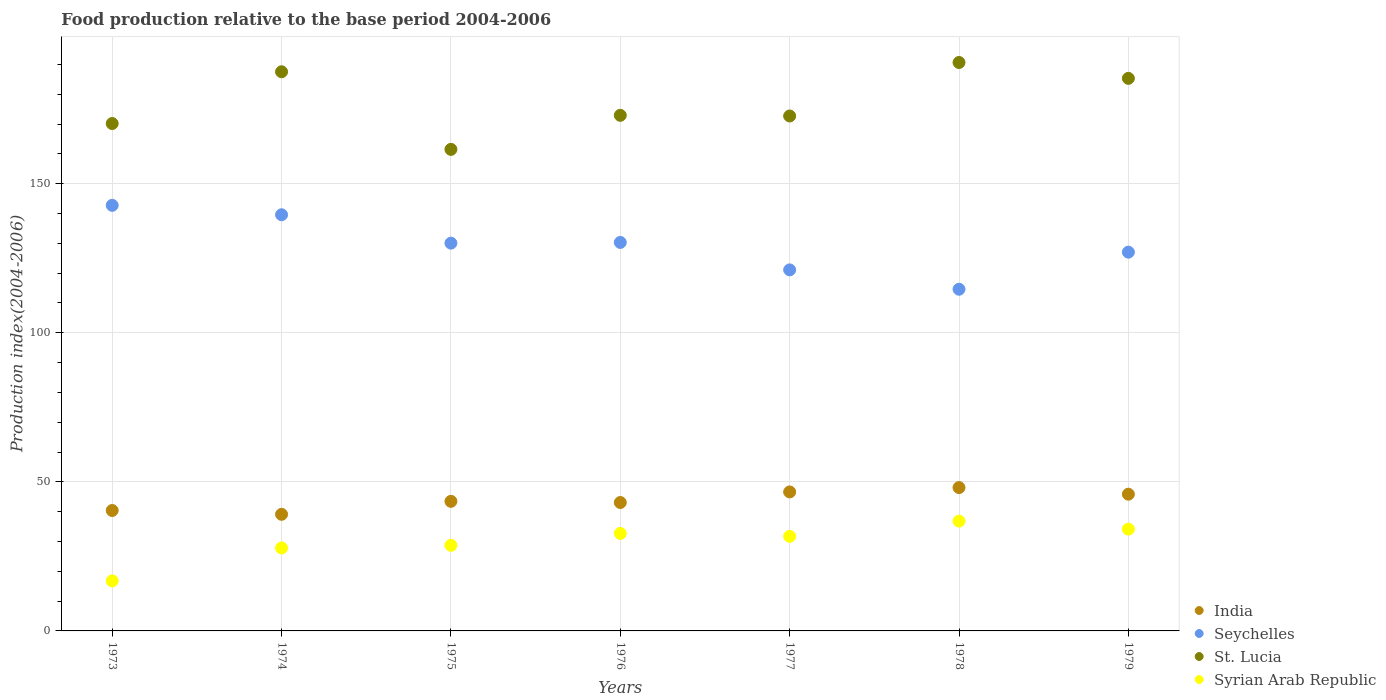What is the food production index in Syrian Arab Republic in 1978?
Your response must be concise. 36.83. Across all years, what is the maximum food production index in Seychelles?
Your answer should be compact. 142.74. Across all years, what is the minimum food production index in Syrian Arab Republic?
Offer a terse response. 16.78. In which year was the food production index in Syrian Arab Republic maximum?
Make the answer very short. 1978. In which year was the food production index in Syrian Arab Republic minimum?
Your answer should be compact. 1973. What is the total food production index in St. Lucia in the graph?
Give a very brief answer. 1240.85. What is the difference between the food production index in India in 1977 and that in 1978?
Provide a succinct answer. -1.46. What is the difference between the food production index in St. Lucia in 1973 and the food production index in Seychelles in 1978?
Keep it short and to the point. 55.58. What is the average food production index in Syrian Arab Republic per year?
Provide a short and direct response. 29.81. In the year 1973, what is the difference between the food production index in Seychelles and food production index in Syrian Arab Republic?
Offer a terse response. 125.96. In how many years, is the food production index in Seychelles greater than 10?
Provide a succinct answer. 7. What is the ratio of the food production index in India in 1973 to that in 1974?
Offer a very short reply. 1.03. What is the difference between the highest and the second highest food production index in St. Lucia?
Your answer should be very brief. 3.11. What is the difference between the highest and the lowest food production index in Syrian Arab Republic?
Provide a short and direct response. 20.05. Is the sum of the food production index in Syrian Arab Republic in 1973 and 1976 greater than the maximum food production index in India across all years?
Offer a very short reply. Yes. Is it the case that in every year, the sum of the food production index in Seychelles and food production index in St. Lucia  is greater than the sum of food production index in Syrian Arab Republic and food production index in India?
Your answer should be compact. Yes. Is it the case that in every year, the sum of the food production index in St. Lucia and food production index in Seychelles  is greater than the food production index in Syrian Arab Republic?
Your answer should be compact. Yes. Is the food production index in Syrian Arab Republic strictly greater than the food production index in India over the years?
Provide a short and direct response. No. Is the food production index in Seychelles strictly less than the food production index in St. Lucia over the years?
Give a very brief answer. Yes. How many dotlines are there?
Provide a succinct answer. 4. What is the difference between two consecutive major ticks on the Y-axis?
Your response must be concise. 50. Are the values on the major ticks of Y-axis written in scientific E-notation?
Keep it short and to the point. No. Does the graph contain any zero values?
Give a very brief answer. No. Does the graph contain grids?
Your answer should be very brief. Yes. Where does the legend appear in the graph?
Offer a terse response. Bottom right. How many legend labels are there?
Provide a short and direct response. 4. How are the legend labels stacked?
Provide a succinct answer. Vertical. What is the title of the graph?
Keep it short and to the point. Food production relative to the base period 2004-2006. What is the label or title of the Y-axis?
Make the answer very short. Production index(2004-2006). What is the Production index(2004-2006) of India in 1973?
Ensure brevity in your answer.  40.39. What is the Production index(2004-2006) in Seychelles in 1973?
Keep it short and to the point. 142.74. What is the Production index(2004-2006) in St. Lucia in 1973?
Your answer should be compact. 170.18. What is the Production index(2004-2006) of Syrian Arab Republic in 1973?
Ensure brevity in your answer.  16.78. What is the Production index(2004-2006) in India in 1974?
Ensure brevity in your answer.  39.11. What is the Production index(2004-2006) in Seychelles in 1974?
Give a very brief answer. 139.58. What is the Production index(2004-2006) of St. Lucia in 1974?
Keep it short and to the point. 187.54. What is the Production index(2004-2006) of Syrian Arab Republic in 1974?
Provide a short and direct response. 27.83. What is the Production index(2004-2006) in India in 1975?
Ensure brevity in your answer.  43.46. What is the Production index(2004-2006) of Seychelles in 1975?
Give a very brief answer. 130.06. What is the Production index(2004-2006) in St. Lucia in 1975?
Your answer should be compact. 161.51. What is the Production index(2004-2006) of Syrian Arab Republic in 1975?
Your answer should be very brief. 28.7. What is the Production index(2004-2006) in India in 1976?
Your answer should be very brief. 43.07. What is the Production index(2004-2006) in Seychelles in 1976?
Your answer should be compact. 130.3. What is the Production index(2004-2006) in St. Lucia in 1976?
Provide a short and direct response. 172.93. What is the Production index(2004-2006) of Syrian Arab Republic in 1976?
Your answer should be very brief. 32.69. What is the Production index(2004-2006) in India in 1977?
Provide a succinct answer. 46.62. What is the Production index(2004-2006) of Seychelles in 1977?
Ensure brevity in your answer.  121.09. What is the Production index(2004-2006) in St. Lucia in 1977?
Give a very brief answer. 172.71. What is the Production index(2004-2006) in Syrian Arab Republic in 1977?
Make the answer very short. 31.72. What is the Production index(2004-2006) of India in 1978?
Your response must be concise. 48.08. What is the Production index(2004-2006) in Seychelles in 1978?
Provide a short and direct response. 114.6. What is the Production index(2004-2006) of St. Lucia in 1978?
Ensure brevity in your answer.  190.65. What is the Production index(2004-2006) in Syrian Arab Republic in 1978?
Offer a very short reply. 36.83. What is the Production index(2004-2006) of India in 1979?
Give a very brief answer. 45.86. What is the Production index(2004-2006) of Seychelles in 1979?
Keep it short and to the point. 127.04. What is the Production index(2004-2006) of St. Lucia in 1979?
Make the answer very short. 185.33. What is the Production index(2004-2006) in Syrian Arab Republic in 1979?
Your answer should be compact. 34.15. Across all years, what is the maximum Production index(2004-2006) in India?
Your answer should be very brief. 48.08. Across all years, what is the maximum Production index(2004-2006) in Seychelles?
Keep it short and to the point. 142.74. Across all years, what is the maximum Production index(2004-2006) of St. Lucia?
Offer a very short reply. 190.65. Across all years, what is the maximum Production index(2004-2006) in Syrian Arab Republic?
Provide a short and direct response. 36.83. Across all years, what is the minimum Production index(2004-2006) of India?
Make the answer very short. 39.11. Across all years, what is the minimum Production index(2004-2006) of Seychelles?
Offer a terse response. 114.6. Across all years, what is the minimum Production index(2004-2006) of St. Lucia?
Provide a short and direct response. 161.51. Across all years, what is the minimum Production index(2004-2006) of Syrian Arab Republic?
Keep it short and to the point. 16.78. What is the total Production index(2004-2006) of India in the graph?
Make the answer very short. 306.59. What is the total Production index(2004-2006) in Seychelles in the graph?
Make the answer very short. 905.41. What is the total Production index(2004-2006) in St. Lucia in the graph?
Offer a terse response. 1240.85. What is the total Production index(2004-2006) of Syrian Arab Republic in the graph?
Offer a very short reply. 208.7. What is the difference between the Production index(2004-2006) in India in 1973 and that in 1974?
Keep it short and to the point. 1.28. What is the difference between the Production index(2004-2006) of Seychelles in 1973 and that in 1974?
Give a very brief answer. 3.16. What is the difference between the Production index(2004-2006) of St. Lucia in 1973 and that in 1974?
Keep it short and to the point. -17.36. What is the difference between the Production index(2004-2006) of Syrian Arab Republic in 1973 and that in 1974?
Provide a short and direct response. -11.05. What is the difference between the Production index(2004-2006) in India in 1973 and that in 1975?
Ensure brevity in your answer.  -3.07. What is the difference between the Production index(2004-2006) in Seychelles in 1973 and that in 1975?
Keep it short and to the point. 12.68. What is the difference between the Production index(2004-2006) of St. Lucia in 1973 and that in 1975?
Ensure brevity in your answer.  8.67. What is the difference between the Production index(2004-2006) in Syrian Arab Republic in 1973 and that in 1975?
Offer a very short reply. -11.92. What is the difference between the Production index(2004-2006) of India in 1973 and that in 1976?
Offer a very short reply. -2.68. What is the difference between the Production index(2004-2006) of Seychelles in 1973 and that in 1976?
Offer a very short reply. 12.44. What is the difference between the Production index(2004-2006) in St. Lucia in 1973 and that in 1976?
Your answer should be compact. -2.75. What is the difference between the Production index(2004-2006) of Syrian Arab Republic in 1973 and that in 1976?
Make the answer very short. -15.91. What is the difference between the Production index(2004-2006) of India in 1973 and that in 1977?
Your answer should be very brief. -6.23. What is the difference between the Production index(2004-2006) in Seychelles in 1973 and that in 1977?
Give a very brief answer. 21.65. What is the difference between the Production index(2004-2006) in St. Lucia in 1973 and that in 1977?
Provide a short and direct response. -2.53. What is the difference between the Production index(2004-2006) in Syrian Arab Republic in 1973 and that in 1977?
Your answer should be very brief. -14.94. What is the difference between the Production index(2004-2006) of India in 1973 and that in 1978?
Provide a succinct answer. -7.69. What is the difference between the Production index(2004-2006) in Seychelles in 1973 and that in 1978?
Your response must be concise. 28.14. What is the difference between the Production index(2004-2006) of St. Lucia in 1973 and that in 1978?
Make the answer very short. -20.47. What is the difference between the Production index(2004-2006) in Syrian Arab Republic in 1973 and that in 1978?
Make the answer very short. -20.05. What is the difference between the Production index(2004-2006) in India in 1973 and that in 1979?
Offer a terse response. -5.47. What is the difference between the Production index(2004-2006) of Seychelles in 1973 and that in 1979?
Provide a short and direct response. 15.7. What is the difference between the Production index(2004-2006) of St. Lucia in 1973 and that in 1979?
Provide a succinct answer. -15.15. What is the difference between the Production index(2004-2006) of Syrian Arab Republic in 1973 and that in 1979?
Ensure brevity in your answer.  -17.37. What is the difference between the Production index(2004-2006) of India in 1974 and that in 1975?
Offer a terse response. -4.35. What is the difference between the Production index(2004-2006) of Seychelles in 1974 and that in 1975?
Your response must be concise. 9.52. What is the difference between the Production index(2004-2006) in St. Lucia in 1974 and that in 1975?
Offer a very short reply. 26.03. What is the difference between the Production index(2004-2006) in Syrian Arab Republic in 1974 and that in 1975?
Give a very brief answer. -0.87. What is the difference between the Production index(2004-2006) in India in 1974 and that in 1976?
Your answer should be very brief. -3.96. What is the difference between the Production index(2004-2006) of Seychelles in 1974 and that in 1976?
Offer a very short reply. 9.28. What is the difference between the Production index(2004-2006) of St. Lucia in 1974 and that in 1976?
Your response must be concise. 14.61. What is the difference between the Production index(2004-2006) of Syrian Arab Republic in 1974 and that in 1976?
Your response must be concise. -4.86. What is the difference between the Production index(2004-2006) in India in 1974 and that in 1977?
Offer a terse response. -7.51. What is the difference between the Production index(2004-2006) in Seychelles in 1974 and that in 1977?
Your response must be concise. 18.49. What is the difference between the Production index(2004-2006) of St. Lucia in 1974 and that in 1977?
Offer a terse response. 14.83. What is the difference between the Production index(2004-2006) in Syrian Arab Republic in 1974 and that in 1977?
Ensure brevity in your answer.  -3.89. What is the difference between the Production index(2004-2006) of India in 1974 and that in 1978?
Provide a succinct answer. -8.97. What is the difference between the Production index(2004-2006) in Seychelles in 1974 and that in 1978?
Offer a terse response. 24.98. What is the difference between the Production index(2004-2006) in St. Lucia in 1974 and that in 1978?
Your answer should be compact. -3.11. What is the difference between the Production index(2004-2006) in Syrian Arab Republic in 1974 and that in 1978?
Give a very brief answer. -9. What is the difference between the Production index(2004-2006) of India in 1974 and that in 1979?
Offer a very short reply. -6.75. What is the difference between the Production index(2004-2006) of Seychelles in 1974 and that in 1979?
Offer a terse response. 12.54. What is the difference between the Production index(2004-2006) in St. Lucia in 1974 and that in 1979?
Offer a terse response. 2.21. What is the difference between the Production index(2004-2006) of Syrian Arab Republic in 1974 and that in 1979?
Ensure brevity in your answer.  -6.32. What is the difference between the Production index(2004-2006) of India in 1975 and that in 1976?
Your answer should be compact. 0.39. What is the difference between the Production index(2004-2006) of Seychelles in 1975 and that in 1976?
Make the answer very short. -0.24. What is the difference between the Production index(2004-2006) in St. Lucia in 1975 and that in 1976?
Offer a terse response. -11.42. What is the difference between the Production index(2004-2006) of Syrian Arab Republic in 1975 and that in 1976?
Your response must be concise. -3.99. What is the difference between the Production index(2004-2006) of India in 1975 and that in 1977?
Offer a very short reply. -3.16. What is the difference between the Production index(2004-2006) of Seychelles in 1975 and that in 1977?
Keep it short and to the point. 8.97. What is the difference between the Production index(2004-2006) of St. Lucia in 1975 and that in 1977?
Provide a succinct answer. -11.2. What is the difference between the Production index(2004-2006) of Syrian Arab Republic in 1975 and that in 1977?
Ensure brevity in your answer.  -3.02. What is the difference between the Production index(2004-2006) in India in 1975 and that in 1978?
Make the answer very short. -4.62. What is the difference between the Production index(2004-2006) in Seychelles in 1975 and that in 1978?
Keep it short and to the point. 15.46. What is the difference between the Production index(2004-2006) in St. Lucia in 1975 and that in 1978?
Offer a terse response. -29.14. What is the difference between the Production index(2004-2006) of Syrian Arab Republic in 1975 and that in 1978?
Keep it short and to the point. -8.13. What is the difference between the Production index(2004-2006) of Seychelles in 1975 and that in 1979?
Your answer should be compact. 3.02. What is the difference between the Production index(2004-2006) of St. Lucia in 1975 and that in 1979?
Ensure brevity in your answer.  -23.82. What is the difference between the Production index(2004-2006) of Syrian Arab Republic in 1975 and that in 1979?
Your response must be concise. -5.45. What is the difference between the Production index(2004-2006) of India in 1976 and that in 1977?
Keep it short and to the point. -3.55. What is the difference between the Production index(2004-2006) of Seychelles in 1976 and that in 1977?
Provide a succinct answer. 9.21. What is the difference between the Production index(2004-2006) of St. Lucia in 1976 and that in 1977?
Offer a terse response. 0.22. What is the difference between the Production index(2004-2006) of India in 1976 and that in 1978?
Make the answer very short. -5.01. What is the difference between the Production index(2004-2006) of St. Lucia in 1976 and that in 1978?
Offer a terse response. -17.72. What is the difference between the Production index(2004-2006) in Syrian Arab Republic in 1976 and that in 1978?
Your response must be concise. -4.14. What is the difference between the Production index(2004-2006) of India in 1976 and that in 1979?
Offer a very short reply. -2.79. What is the difference between the Production index(2004-2006) of Seychelles in 1976 and that in 1979?
Provide a short and direct response. 3.26. What is the difference between the Production index(2004-2006) in Syrian Arab Republic in 1976 and that in 1979?
Ensure brevity in your answer.  -1.46. What is the difference between the Production index(2004-2006) of India in 1977 and that in 1978?
Ensure brevity in your answer.  -1.46. What is the difference between the Production index(2004-2006) in Seychelles in 1977 and that in 1978?
Keep it short and to the point. 6.49. What is the difference between the Production index(2004-2006) in St. Lucia in 1977 and that in 1978?
Keep it short and to the point. -17.94. What is the difference between the Production index(2004-2006) of Syrian Arab Republic in 1977 and that in 1978?
Your answer should be compact. -5.11. What is the difference between the Production index(2004-2006) of India in 1977 and that in 1979?
Offer a very short reply. 0.76. What is the difference between the Production index(2004-2006) of Seychelles in 1977 and that in 1979?
Give a very brief answer. -5.95. What is the difference between the Production index(2004-2006) of St. Lucia in 1977 and that in 1979?
Make the answer very short. -12.62. What is the difference between the Production index(2004-2006) in Syrian Arab Republic in 1977 and that in 1979?
Your answer should be very brief. -2.43. What is the difference between the Production index(2004-2006) of India in 1978 and that in 1979?
Your response must be concise. 2.22. What is the difference between the Production index(2004-2006) of Seychelles in 1978 and that in 1979?
Provide a succinct answer. -12.44. What is the difference between the Production index(2004-2006) in St. Lucia in 1978 and that in 1979?
Give a very brief answer. 5.32. What is the difference between the Production index(2004-2006) of Syrian Arab Republic in 1978 and that in 1979?
Provide a succinct answer. 2.68. What is the difference between the Production index(2004-2006) in India in 1973 and the Production index(2004-2006) in Seychelles in 1974?
Your answer should be very brief. -99.19. What is the difference between the Production index(2004-2006) in India in 1973 and the Production index(2004-2006) in St. Lucia in 1974?
Ensure brevity in your answer.  -147.15. What is the difference between the Production index(2004-2006) of India in 1973 and the Production index(2004-2006) of Syrian Arab Republic in 1974?
Provide a succinct answer. 12.56. What is the difference between the Production index(2004-2006) of Seychelles in 1973 and the Production index(2004-2006) of St. Lucia in 1974?
Make the answer very short. -44.8. What is the difference between the Production index(2004-2006) of Seychelles in 1973 and the Production index(2004-2006) of Syrian Arab Republic in 1974?
Provide a short and direct response. 114.91. What is the difference between the Production index(2004-2006) of St. Lucia in 1973 and the Production index(2004-2006) of Syrian Arab Republic in 1974?
Make the answer very short. 142.35. What is the difference between the Production index(2004-2006) in India in 1973 and the Production index(2004-2006) in Seychelles in 1975?
Provide a succinct answer. -89.67. What is the difference between the Production index(2004-2006) in India in 1973 and the Production index(2004-2006) in St. Lucia in 1975?
Make the answer very short. -121.12. What is the difference between the Production index(2004-2006) in India in 1973 and the Production index(2004-2006) in Syrian Arab Republic in 1975?
Ensure brevity in your answer.  11.69. What is the difference between the Production index(2004-2006) of Seychelles in 1973 and the Production index(2004-2006) of St. Lucia in 1975?
Your response must be concise. -18.77. What is the difference between the Production index(2004-2006) of Seychelles in 1973 and the Production index(2004-2006) of Syrian Arab Republic in 1975?
Your response must be concise. 114.04. What is the difference between the Production index(2004-2006) in St. Lucia in 1973 and the Production index(2004-2006) in Syrian Arab Republic in 1975?
Offer a terse response. 141.48. What is the difference between the Production index(2004-2006) in India in 1973 and the Production index(2004-2006) in Seychelles in 1976?
Keep it short and to the point. -89.91. What is the difference between the Production index(2004-2006) of India in 1973 and the Production index(2004-2006) of St. Lucia in 1976?
Ensure brevity in your answer.  -132.54. What is the difference between the Production index(2004-2006) of India in 1973 and the Production index(2004-2006) of Syrian Arab Republic in 1976?
Offer a terse response. 7.7. What is the difference between the Production index(2004-2006) of Seychelles in 1973 and the Production index(2004-2006) of St. Lucia in 1976?
Your answer should be compact. -30.19. What is the difference between the Production index(2004-2006) in Seychelles in 1973 and the Production index(2004-2006) in Syrian Arab Republic in 1976?
Your answer should be very brief. 110.05. What is the difference between the Production index(2004-2006) of St. Lucia in 1973 and the Production index(2004-2006) of Syrian Arab Republic in 1976?
Provide a short and direct response. 137.49. What is the difference between the Production index(2004-2006) in India in 1973 and the Production index(2004-2006) in Seychelles in 1977?
Make the answer very short. -80.7. What is the difference between the Production index(2004-2006) of India in 1973 and the Production index(2004-2006) of St. Lucia in 1977?
Give a very brief answer. -132.32. What is the difference between the Production index(2004-2006) of India in 1973 and the Production index(2004-2006) of Syrian Arab Republic in 1977?
Ensure brevity in your answer.  8.67. What is the difference between the Production index(2004-2006) in Seychelles in 1973 and the Production index(2004-2006) in St. Lucia in 1977?
Keep it short and to the point. -29.97. What is the difference between the Production index(2004-2006) of Seychelles in 1973 and the Production index(2004-2006) of Syrian Arab Republic in 1977?
Keep it short and to the point. 111.02. What is the difference between the Production index(2004-2006) in St. Lucia in 1973 and the Production index(2004-2006) in Syrian Arab Republic in 1977?
Make the answer very short. 138.46. What is the difference between the Production index(2004-2006) of India in 1973 and the Production index(2004-2006) of Seychelles in 1978?
Your answer should be compact. -74.21. What is the difference between the Production index(2004-2006) of India in 1973 and the Production index(2004-2006) of St. Lucia in 1978?
Your answer should be compact. -150.26. What is the difference between the Production index(2004-2006) in India in 1973 and the Production index(2004-2006) in Syrian Arab Republic in 1978?
Ensure brevity in your answer.  3.56. What is the difference between the Production index(2004-2006) in Seychelles in 1973 and the Production index(2004-2006) in St. Lucia in 1978?
Make the answer very short. -47.91. What is the difference between the Production index(2004-2006) of Seychelles in 1973 and the Production index(2004-2006) of Syrian Arab Republic in 1978?
Keep it short and to the point. 105.91. What is the difference between the Production index(2004-2006) in St. Lucia in 1973 and the Production index(2004-2006) in Syrian Arab Republic in 1978?
Your answer should be compact. 133.35. What is the difference between the Production index(2004-2006) in India in 1973 and the Production index(2004-2006) in Seychelles in 1979?
Offer a very short reply. -86.65. What is the difference between the Production index(2004-2006) of India in 1973 and the Production index(2004-2006) of St. Lucia in 1979?
Keep it short and to the point. -144.94. What is the difference between the Production index(2004-2006) of India in 1973 and the Production index(2004-2006) of Syrian Arab Republic in 1979?
Your answer should be very brief. 6.24. What is the difference between the Production index(2004-2006) in Seychelles in 1973 and the Production index(2004-2006) in St. Lucia in 1979?
Your answer should be very brief. -42.59. What is the difference between the Production index(2004-2006) in Seychelles in 1973 and the Production index(2004-2006) in Syrian Arab Republic in 1979?
Ensure brevity in your answer.  108.59. What is the difference between the Production index(2004-2006) of St. Lucia in 1973 and the Production index(2004-2006) of Syrian Arab Republic in 1979?
Provide a short and direct response. 136.03. What is the difference between the Production index(2004-2006) in India in 1974 and the Production index(2004-2006) in Seychelles in 1975?
Give a very brief answer. -90.95. What is the difference between the Production index(2004-2006) in India in 1974 and the Production index(2004-2006) in St. Lucia in 1975?
Ensure brevity in your answer.  -122.4. What is the difference between the Production index(2004-2006) in India in 1974 and the Production index(2004-2006) in Syrian Arab Republic in 1975?
Keep it short and to the point. 10.41. What is the difference between the Production index(2004-2006) in Seychelles in 1974 and the Production index(2004-2006) in St. Lucia in 1975?
Make the answer very short. -21.93. What is the difference between the Production index(2004-2006) of Seychelles in 1974 and the Production index(2004-2006) of Syrian Arab Republic in 1975?
Make the answer very short. 110.88. What is the difference between the Production index(2004-2006) in St. Lucia in 1974 and the Production index(2004-2006) in Syrian Arab Republic in 1975?
Your answer should be very brief. 158.84. What is the difference between the Production index(2004-2006) in India in 1974 and the Production index(2004-2006) in Seychelles in 1976?
Provide a short and direct response. -91.19. What is the difference between the Production index(2004-2006) of India in 1974 and the Production index(2004-2006) of St. Lucia in 1976?
Your response must be concise. -133.82. What is the difference between the Production index(2004-2006) of India in 1974 and the Production index(2004-2006) of Syrian Arab Republic in 1976?
Ensure brevity in your answer.  6.42. What is the difference between the Production index(2004-2006) of Seychelles in 1974 and the Production index(2004-2006) of St. Lucia in 1976?
Make the answer very short. -33.35. What is the difference between the Production index(2004-2006) in Seychelles in 1974 and the Production index(2004-2006) in Syrian Arab Republic in 1976?
Your response must be concise. 106.89. What is the difference between the Production index(2004-2006) of St. Lucia in 1974 and the Production index(2004-2006) of Syrian Arab Republic in 1976?
Make the answer very short. 154.85. What is the difference between the Production index(2004-2006) of India in 1974 and the Production index(2004-2006) of Seychelles in 1977?
Provide a succinct answer. -81.98. What is the difference between the Production index(2004-2006) of India in 1974 and the Production index(2004-2006) of St. Lucia in 1977?
Provide a short and direct response. -133.6. What is the difference between the Production index(2004-2006) of India in 1974 and the Production index(2004-2006) of Syrian Arab Republic in 1977?
Make the answer very short. 7.39. What is the difference between the Production index(2004-2006) of Seychelles in 1974 and the Production index(2004-2006) of St. Lucia in 1977?
Your response must be concise. -33.13. What is the difference between the Production index(2004-2006) in Seychelles in 1974 and the Production index(2004-2006) in Syrian Arab Republic in 1977?
Your answer should be compact. 107.86. What is the difference between the Production index(2004-2006) of St. Lucia in 1974 and the Production index(2004-2006) of Syrian Arab Republic in 1977?
Keep it short and to the point. 155.82. What is the difference between the Production index(2004-2006) of India in 1974 and the Production index(2004-2006) of Seychelles in 1978?
Your response must be concise. -75.49. What is the difference between the Production index(2004-2006) in India in 1974 and the Production index(2004-2006) in St. Lucia in 1978?
Keep it short and to the point. -151.54. What is the difference between the Production index(2004-2006) of India in 1974 and the Production index(2004-2006) of Syrian Arab Republic in 1978?
Offer a terse response. 2.28. What is the difference between the Production index(2004-2006) in Seychelles in 1974 and the Production index(2004-2006) in St. Lucia in 1978?
Ensure brevity in your answer.  -51.07. What is the difference between the Production index(2004-2006) in Seychelles in 1974 and the Production index(2004-2006) in Syrian Arab Republic in 1978?
Ensure brevity in your answer.  102.75. What is the difference between the Production index(2004-2006) in St. Lucia in 1974 and the Production index(2004-2006) in Syrian Arab Republic in 1978?
Your response must be concise. 150.71. What is the difference between the Production index(2004-2006) of India in 1974 and the Production index(2004-2006) of Seychelles in 1979?
Provide a short and direct response. -87.93. What is the difference between the Production index(2004-2006) of India in 1974 and the Production index(2004-2006) of St. Lucia in 1979?
Provide a succinct answer. -146.22. What is the difference between the Production index(2004-2006) in India in 1974 and the Production index(2004-2006) in Syrian Arab Republic in 1979?
Offer a terse response. 4.96. What is the difference between the Production index(2004-2006) in Seychelles in 1974 and the Production index(2004-2006) in St. Lucia in 1979?
Provide a succinct answer. -45.75. What is the difference between the Production index(2004-2006) in Seychelles in 1974 and the Production index(2004-2006) in Syrian Arab Republic in 1979?
Your response must be concise. 105.43. What is the difference between the Production index(2004-2006) of St. Lucia in 1974 and the Production index(2004-2006) of Syrian Arab Republic in 1979?
Ensure brevity in your answer.  153.39. What is the difference between the Production index(2004-2006) in India in 1975 and the Production index(2004-2006) in Seychelles in 1976?
Your answer should be compact. -86.84. What is the difference between the Production index(2004-2006) in India in 1975 and the Production index(2004-2006) in St. Lucia in 1976?
Your answer should be compact. -129.47. What is the difference between the Production index(2004-2006) in India in 1975 and the Production index(2004-2006) in Syrian Arab Republic in 1976?
Your answer should be very brief. 10.77. What is the difference between the Production index(2004-2006) of Seychelles in 1975 and the Production index(2004-2006) of St. Lucia in 1976?
Your answer should be compact. -42.87. What is the difference between the Production index(2004-2006) of Seychelles in 1975 and the Production index(2004-2006) of Syrian Arab Republic in 1976?
Your answer should be very brief. 97.37. What is the difference between the Production index(2004-2006) of St. Lucia in 1975 and the Production index(2004-2006) of Syrian Arab Republic in 1976?
Provide a succinct answer. 128.82. What is the difference between the Production index(2004-2006) of India in 1975 and the Production index(2004-2006) of Seychelles in 1977?
Offer a terse response. -77.63. What is the difference between the Production index(2004-2006) in India in 1975 and the Production index(2004-2006) in St. Lucia in 1977?
Your answer should be compact. -129.25. What is the difference between the Production index(2004-2006) in India in 1975 and the Production index(2004-2006) in Syrian Arab Republic in 1977?
Provide a succinct answer. 11.74. What is the difference between the Production index(2004-2006) in Seychelles in 1975 and the Production index(2004-2006) in St. Lucia in 1977?
Your answer should be compact. -42.65. What is the difference between the Production index(2004-2006) in Seychelles in 1975 and the Production index(2004-2006) in Syrian Arab Republic in 1977?
Provide a short and direct response. 98.34. What is the difference between the Production index(2004-2006) in St. Lucia in 1975 and the Production index(2004-2006) in Syrian Arab Republic in 1977?
Offer a terse response. 129.79. What is the difference between the Production index(2004-2006) of India in 1975 and the Production index(2004-2006) of Seychelles in 1978?
Provide a succinct answer. -71.14. What is the difference between the Production index(2004-2006) of India in 1975 and the Production index(2004-2006) of St. Lucia in 1978?
Your answer should be compact. -147.19. What is the difference between the Production index(2004-2006) of India in 1975 and the Production index(2004-2006) of Syrian Arab Republic in 1978?
Keep it short and to the point. 6.63. What is the difference between the Production index(2004-2006) in Seychelles in 1975 and the Production index(2004-2006) in St. Lucia in 1978?
Give a very brief answer. -60.59. What is the difference between the Production index(2004-2006) of Seychelles in 1975 and the Production index(2004-2006) of Syrian Arab Republic in 1978?
Your response must be concise. 93.23. What is the difference between the Production index(2004-2006) of St. Lucia in 1975 and the Production index(2004-2006) of Syrian Arab Republic in 1978?
Provide a succinct answer. 124.68. What is the difference between the Production index(2004-2006) of India in 1975 and the Production index(2004-2006) of Seychelles in 1979?
Make the answer very short. -83.58. What is the difference between the Production index(2004-2006) in India in 1975 and the Production index(2004-2006) in St. Lucia in 1979?
Provide a succinct answer. -141.87. What is the difference between the Production index(2004-2006) in India in 1975 and the Production index(2004-2006) in Syrian Arab Republic in 1979?
Ensure brevity in your answer.  9.31. What is the difference between the Production index(2004-2006) in Seychelles in 1975 and the Production index(2004-2006) in St. Lucia in 1979?
Keep it short and to the point. -55.27. What is the difference between the Production index(2004-2006) of Seychelles in 1975 and the Production index(2004-2006) of Syrian Arab Republic in 1979?
Ensure brevity in your answer.  95.91. What is the difference between the Production index(2004-2006) in St. Lucia in 1975 and the Production index(2004-2006) in Syrian Arab Republic in 1979?
Ensure brevity in your answer.  127.36. What is the difference between the Production index(2004-2006) of India in 1976 and the Production index(2004-2006) of Seychelles in 1977?
Give a very brief answer. -78.02. What is the difference between the Production index(2004-2006) of India in 1976 and the Production index(2004-2006) of St. Lucia in 1977?
Provide a succinct answer. -129.64. What is the difference between the Production index(2004-2006) of India in 1976 and the Production index(2004-2006) of Syrian Arab Republic in 1977?
Your answer should be compact. 11.35. What is the difference between the Production index(2004-2006) of Seychelles in 1976 and the Production index(2004-2006) of St. Lucia in 1977?
Ensure brevity in your answer.  -42.41. What is the difference between the Production index(2004-2006) of Seychelles in 1976 and the Production index(2004-2006) of Syrian Arab Republic in 1977?
Provide a short and direct response. 98.58. What is the difference between the Production index(2004-2006) of St. Lucia in 1976 and the Production index(2004-2006) of Syrian Arab Republic in 1977?
Ensure brevity in your answer.  141.21. What is the difference between the Production index(2004-2006) in India in 1976 and the Production index(2004-2006) in Seychelles in 1978?
Your answer should be very brief. -71.53. What is the difference between the Production index(2004-2006) of India in 1976 and the Production index(2004-2006) of St. Lucia in 1978?
Ensure brevity in your answer.  -147.58. What is the difference between the Production index(2004-2006) of India in 1976 and the Production index(2004-2006) of Syrian Arab Republic in 1978?
Provide a short and direct response. 6.24. What is the difference between the Production index(2004-2006) in Seychelles in 1976 and the Production index(2004-2006) in St. Lucia in 1978?
Your answer should be very brief. -60.35. What is the difference between the Production index(2004-2006) in Seychelles in 1976 and the Production index(2004-2006) in Syrian Arab Republic in 1978?
Provide a succinct answer. 93.47. What is the difference between the Production index(2004-2006) of St. Lucia in 1976 and the Production index(2004-2006) of Syrian Arab Republic in 1978?
Offer a very short reply. 136.1. What is the difference between the Production index(2004-2006) in India in 1976 and the Production index(2004-2006) in Seychelles in 1979?
Your answer should be compact. -83.97. What is the difference between the Production index(2004-2006) of India in 1976 and the Production index(2004-2006) of St. Lucia in 1979?
Give a very brief answer. -142.26. What is the difference between the Production index(2004-2006) in India in 1976 and the Production index(2004-2006) in Syrian Arab Republic in 1979?
Your answer should be compact. 8.92. What is the difference between the Production index(2004-2006) of Seychelles in 1976 and the Production index(2004-2006) of St. Lucia in 1979?
Provide a succinct answer. -55.03. What is the difference between the Production index(2004-2006) in Seychelles in 1976 and the Production index(2004-2006) in Syrian Arab Republic in 1979?
Offer a very short reply. 96.15. What is the difference between the Production index(2004-2006) in St. Lucia in 1976 and the Production index(2004-2006) in Syrian Arab Republic in 1979?
Provide a succinct answer. 138.78. What is the difference between the Production index(2004-2006) in India in 1977 and the Production index(2004-2006) in Seychelles in 1978?
Your answer should be compact. -67.98. What is the difference between the Production index(2004-2006) in India in 1977 and the Production index(2004-2006) in St. Lucia in 1978?
Your answer should be very brief. -144.03. What is the difference between the Production index(2004-2006) in India in 1977 and the Production index(2004-2006) in Syrian Arab Republic in 1978?
Make the answer very short. 9.79. What is the difference between the Production index(2004-2006) of Seychelles in 1977 and the Production index(2004-2006) of St. Lucia in 1978?
Ensure brevity in your answer.  -69.56. What is the difference between the Production index(2004-2006) of Seychelles in 1977 and the Production index(2004-2006) of Syrian Arab Republic in 1978?
Your answer should be compact. 84.26. What is the difference between the Production index(2004-2006) of St. Lucia in 1977 and the Production index(2004-2006) of Syrian Arab Republic in 1978?
Provide a succinct answer. 135.88. What is the difference between the Production index(2004-2006) in India in 1977 and the Production index(2004-2006) in Seychelles in 1979?
Give a very brief answer. -80.42. What is the difference between the Production index(2004-2006) of India in 1977 and the Production index(2004-2006) of St. Lucia in 1979?
Ensure brevity in your answer.  -138.71. What is the difference between the Production index(2004-2006) of India in 1977 and the Production index(2004-2006) of Syrian Arab Republic in 1979?
Your answer should be compact. 12.47. What is the difference between the Production index(2004-2006) in Seychelles in 1977 and the Production index(2004-2006) in St. Lucia in 1979?
Your response must be concise. -64.24. What is the difference between the Production index(2004-2006) of Seychelles in 1977 and the Production index(2004-2006) of Syrian Arab Republic in 1979?
Ensure brevity in your answer.  86.94. What is the difference between the Production index(2004-2006) of St. Lucia in 1977 and the Production index(2004-2006) of Syrian Arab Republic in 1979?
Ensure brevity in your answer.  138.56. What is the difference between the Production index(2004-2006) in India in 1978 and the Production index(2004-2006) in Seychelles in 1979?
Your answer should be compact. -78.96. What is the difference between the Production index(2004-2006) in India in 1978 and the Production index(2004-2006) in St. Lucia in 1979?
Make the answer very short. -137.25. What is the difference between the Production index(2004-2006) in India in 1978 and the Production index(2004-2006) in Syrian Arab Republic in 1979?
Ensure brevity in your answer.  13.93. What is the difference between the Production index(2004-2006) of Seychelles in 1978 and the Production index(2004-2006) of St. Lucia in 1979?
Give a very brief answer. -70.73. What is the difference between the Production index(2004-2006) in Seychelles in 1978 and the Production index(2004-2006) in Syrian Arab Republic in 1979?
Keep it short and to the point. 80.45. What is the difference between the Production index(2004-2006) of St. Lucia in 1978 and the Production index(2004-2006) of Syrian Arab Republic in 1979?
Keep it short and to the point. 156.5. What is the average Production index(2004-2006) in India per year?
Provide a succinct answer. 43.8. What is the average Production index(2004-2006) of Seychelles per year?
Keep it short and to the point. 129.34. What is the average Production index(2004-2006) of St. Lucia per year?
Your response must be concise. 177.26. What is the average Production index(2004-2006) of Syrian Arab Republic per year?
Provide a succinct answer. 29.81. In the year 1973, what is the difference between the Production index(2004-2006) of India and Production index(2004-2006) of Seychelles?
Provide a succinct answer. -102.35. In the year 1973, what is the difference between the Production index(2004-2006) of India and Production index(2004-2006) of St. Lucia?
Ensure brevity in your answer.  -129.79. In the year 1973, what is the difference between the Production index(2004-2006) of India and Production index(2004-2006) of Syrian Arab Republic?
Your response must be concise. 23.61. In the year 1973, what is the difference between the Production index(2004-2006) in Seychelles and Production index(2004-2006) in St. Lucia?
Provide a short and direct response. -27.44. In the year 1973, what is the difference between the Production index(2004-2006) of Seychelles and Production index(2004-2006) of Syrian Arab Republic?
Keep it short and to the point. 125.96. In the year 1973, what is the difference between the Production index(2004-2006) in St. Lucia and Production index(2004-2006) in Syrian Arab Republic?
Provide a succinct answer. 153.4. In the year 1974, what is the difference between the Production index(2004-2006) of India and Production index(2004-2006) of Seychelles?
Offer a terse response. -100.47. In the year 1974, what is the difference between the Production index(2004-2006) in India and Production index(2004-2006) in St. Lucia?
Your answer should be very brief. -148.43. In the year 1974, what is the difference between the Production index(2004-2006) in India and Production index(2004-2006) in Syrian Arab Republic?
Your answer should be very brief. 11.28. In the year 1974, what is the difference between the Production index(2004-2006) in Seychelles and Production index(2004-2006) in St. Lucia?
Give a very brief answer. -47.96. In the year 1974, what is the difference between the Production index(2004-2006) of Seychelles and Production index(2004-2006) of Syrian Arab Republic?
Give a very brief answer. 111.75. In the year 1974, what is the difference between the Production index(2004-2006) of St. Lucia and Production index(2004-2006) of Syrian Arab Republic?
Give a very brief answer. 159.71. In the year 1975, what is the difference between the Production index(2004-2006) of India and Production index(2004-2006) of Seychelles?
Make the answer very short. -86.6. In the year 1975, what is the difference between the Production index(2004-2006) of India and Production index(2004-2006) of St. Lucia?
Your answer should be compact. -118.05. In the year 1975, what is the difference between the Production index(2004-2006) in India and Production index(2004-2006) in Syrian Arab Republic?
Ensure brevity in your answer.  14.76. In the year 1975, what is the difference between the Production index(2004-2006) in Seychelles and Production index(2004-2006) in St. Lucia?
Keep it short and to the point. -31.45. In the year 1975, what is the difference between the Production index(2004-2006) of Seychelles and Production index(2004-2006) of Syrian Arab Republic?
Your response must be concise. 101.36. In the year 1975, what is the difference between the Production index(2004-2006) in St. Lucia and Production index(2004-2006) in Syrian Arab Republic?
Make the answer very short. 132.81. In the year 1976, what is the difference between the Production index(2004-2006) in India and Production index(2004-2006) in Seychelles?
Make the answer very short. -87.23. In the year 1976, what is the difference between the Production index(2004-2006) of India and Production index(2004-2006) of St. Lucia?
Ensure brevity in your answer.  -129.86. In the year 1976, what is the difference between the Production index(2004-2006) of India and Production index(2004-2006) of Syrian Arab Republic?
Ensure brevity in your answer.  10.38. In the year 1976, what is the difference between the Production index(2004-2006) of Seychelles and Production index(2004-2006) of St. Lucia?
Make the answer very short. -42.63. In the year 1976, what is the difference between the Production index(2004-2006) of Seychelles and Production index(2004-2006) of Syrian Arab Republic?
Ensure brevity in your answer.  97.61. In the year 1976, what is the difference between the Production index(2004-2006) in St. Lucia and Production index(2004-2006) in Syrian Arab Republic?
Give a very brief answer. 140.24. In the year 1977, what is the difference between the Production index(2004-2006) of India and Production index(2004-2006) of Seychelles?
Give a very brief answer. -74.47. In the year 1977, what is the difference between the Production index(2004-2006) of India and Production index(2004-2006) of St. Lucia?
Provide a short and direct response. -126.09. In the year 1977, what is the difference between the Production index(2004-2006) of India and Production index(2004-2006) of Syrian Arab Republic?
Provide a succinct answer. 14.9. In the year 1977, what is the difference between the Production index(2004-2006) in Seychelles and Production index(2004-2006) in St. Lucia?
Your answer should be compact. -51.62. In the year 1977, what is the difference between the Production index(2004-2006) in Seychelles and Production index(2004-2006) in Syrian Arab Republic?
Ensure brevity in your answer.  89.37. In the year 1977, what is the difference between the Production index(2004-2006) in St. Lucia and Production index(2004-2006) in Syrian Arab Republic?
Keep it short and to the point. 140.99. In the year 1978, what is the difference between the Production index(2004-2006) of India and Production index(2004-2006) of Seychelles?
Your response must be concise. -66.52. In the year 1978, what is the difference between the Production index(2004-2006) in India and Production index(2004-2006) in St. Lucia?
Provide a succinct answer. -142.57. In the year 1978, what is the difference between the Production index(2004-2006) in India and Production index(2004-2006) in Syrian Arab Republic?
Offer a terse response. 11.25. In the year 1978, what is the difference between the Production index(2004-2006) of Seychelles and Production index(2004-2006) of St. Lucia?
Offer a terse response. -76.05. In the year 1978, what is the difference between the Production index(2004-2006) in Seychelles and Production index(2004-2006) in Syrian Arab Republic?
Offer a terse response. 77.77. In the year 1978, what is the difference between the Production index(2004-2006) of St. Lucia and Production index(2004-2006) of Syrian Arab Republic?
Your response must be concise. 153.82. In the year 1979, what is the difference between the Production index(2004-2006) of India and Production index(2004-2006) of Seychelles?
Your response must be concise. -81.18. In the year 1979, what is the difference between the Production index(2004-2006) in India and Production index(2004-2006) in St. Lucia?
Ensure brevity in your answer.  -139.47. In the year 1979, what is the difference between the Production index(2004-2006) in India and Production index(2004-2006) in Syrian Arab Republic?
Make the answer very short. 11.71. In the year 1979, what is the difference between the Production index(2004-2006) in Seychelles and Production index(2004-2006) in St. Lucia?
Your answer should be compact. -58.29. In the year 1979, what is the difference between the Production index(2004-2006) in Seychelles and Production index(2004-2006) in Syrian Arab Republic?
Give a very brief answer. 92.89. In the year 1979, what is the difference between the Production index(2004-2006) in St. Lucia and Production index(2004-2006) in Syrian Arab Republic?
Ensure brevity in your answer.  151.18. What is the ratio of the Production index(2004-2006) of India in 1973 to that in 1974?
Provide a succinct answer. 1.03. What is the ratio of the Production index(2004-2006) in Seychelles in 1973 to that in 1974?
Keep it short and to the point. 1.02. What is the ratio of the Production index(2004-2006) of St. Lucia in 1973 to that in 1974?
Your answer should be very brief. 0.91. What is the ratio of the Production index(2004-2006) in Syrian Arab Republic in 1973 to that in 1974?
Keep it short and to the point. 0.6. What is the ratio of the Production index(2004-2006) of India in 1973 to that in 1975?
Provide a short and direct response. 0.93. What is the ratio of the Production index(2004-2006) in Seychelles in 1973 to that in 1975?
Keep it short and to the point. 1.1. What is the ratio of the Production index(2004-2006) in St. Lucia in 1973 to that in 1975?
Offer a very short reply. 1.05. What is the ratio of the Production index(2004-2006) in Syrian Arab Republic in 1973 to that in 1975?
Make the answer very short. 0.58. What is the ratio of the Production index(2004-2006) in India in 1973 to that in 1976?
Ensure brevity in your answer.  0.94. What is the ratio of the Production index(2004-2006) in Seychelles in 1973 to that in 1976?
Keep it short and to the point. 1.1. What is the ratio of the Production index(2004-2006) in St. Lucia in 1973 to that in 1976?
Provide a short and direct response. 0.98. What is the ratio of the Production index(2004-2006) in Syrian Arab Republic in 1973 to that in 1976?
Provide a succinct answer. 0.51. What is the ratio of the Production index(2004-2006) in India in 1973 to that in 1977?
Offer a very short reply. 0.87. What is the ratio of the Production index(2004-2006) of Seychelles in 1973 to that in 1977?
Make the answer very short. 1.18. What is the ratio of the Production index(2004-2006) in St. Lucia in 1973 to that in 1977?
Provide a succinct answer. 0.99. What is the ratio of the Production index(2004-2006) of Syrian Arab Republic in 1973 to that in 1977?
Ensure brevity in your answer.  0.53. What is the ratio of the Production index(2004-2006) in India in 1973 to that in 1978?
Your answer should be compact. 0.84. What is the ratio of the Production index(2004-2006) in Seychelles in 1973 to that in 1978?
Your response must be concise. 1.25. What is the ratio of the Production index(2004-2006) of St. Lucia in 1973 to that in 1978?
Make the answer very short. 0.89. What is the ratio of the Production index(2004-2006) of Syrian Arab Republic in 1973 to that in 1978?
Your response must be concise. 0.46. What is the ratio of the Production index(2004-2006) of India in 1973 to that in 1979?
Your answer should be very brief. 0.88. What is the ratio of the Production index(2004-2006) of Seychelles in 1973 to that in 1979?
Ensure brevity in your answer.  1.12. What is the ratio of the Production index(2004-2006) of St. Lucia in 1973 to that in 1979?
Your answer should be very brief. 0.92. What is the ratio of the Production index(2004-2006) of Syrian Arab Republic in 1973 to that in 1979?
Your answer should be compact. 0.49. What is the ratio of the Production index(2004-2006) of India in 1974 to that in 1975?
Make the answer very short. 0.9. What is the ratio of the Production index(2004-2006) of Seychelles in 1974 to that in 1975?
Your response must be concise. 1.07. What is the ratio of the Production index(2004-2006) of St. Lucia in 1974 to that in 1975?
Make the answer very short. 1.16. What is the ratio of the Production index(2004-2006) of Syrian Arab Republic in 1974 to that in 1975?
Give a very brief answer. 0.97. What is the ratio of the Production index(2004-2006) in India in 1974 to that in 1976?
Provide a short and direct response. 0.91. What is the ratio of the Production index(2004-2006) in Seychelles in 1974 to that in 1976?
Provide a short and direct response. 1.07. What is the ratio of the Production index(2004-2006) of St. Lucia in 1974 to that in 1976?
Offer a very short reply. 1.08. What is the ratio of the Production index(2004-2006) in Syrian Arab Republic in 1974 to that in 1976?
Your answer should be compact. 0.85. What is the ratio of the Production index(2004-2006) in India in 1974 to that in 1977?
Offer a terse response. 0.84. What is the ratio of the Production index(2004-2006) in Seychelles in 1974 to that in 1977?
Provide a short and direct response. 1.15. What is the ratio of the Production index(2004-2006) of St. Lucia in 1974 to that in 1977?
Make the answer very short. 1.09. What is the ratio of the Production index(2004-2006) of Syrian Arab Republic in 1974 to that in 1977?
Your answer should be compact. 0.88. What is the ratio of the Production index(2004-2006) in India in 1974 to that in 1978?
Your answer should be compact. 0.81. What is the ratio of the Production index(2004-2006) in Seychelles in 1974 to that in 1978?
Give a very brief answer. 1.22. What is the ratio of the Production index(2004-2006) in St. Lucia in 1974 to that in 1978?
Your answer should be very brief. 0.98. What is the ratio of the Production index(2004-2006) in Syrian Arab Republic in 1974 to that in 1978?
Keep it short and to the point. 0.76. What is the ratio of the Production index(2004-2006) of India in 1974 to that in 1979?
Offer a very short reply. 0.85. What is the ratio of the Production index(2004-2006) in Seychelles in 1974 to that in 1979?
Provide a succinct answer. 1.1. What is the ratio of the Production index(2004-2006) in St. Lucia in 1974 to that in 1979?
Offer a very short reply. 1.01. What is the ratio of the Production index(2004-2006) of Syrian Arab Republic in 1974 to that in 1979?
Offer a terse response. 0.81. What is the ratio of the Production index(2004-2006) in India in 1975 to that in 1976?
Your response must be concise. 1.01. What is the ratio of the Production index(2004-2006) of St. Lucia in 1975 to that in 1976?
Provide a short and direct response. 0.93. What is the ratio of the Production index(2004-2006) in Syrian Arab Republic in 1975 to that in 1976?
Give a very brief answer. 0.88. What is the ratio of the Production index(2004-2006) in India in 1975 to that in 1977?
Offer a very short reply. 0.93. What is the ratio of the Production index(2004-2006) in Seychelles in 1975 to that in 1977?
Your answer should be compact. 1.07. What is the ratio of the Production index(2004-2006) of St. Lucia in 1975 to that in 1977?
Provide a short and direct response. 0.94. What is the ratio of the Production index(2004-2006) of Syrian Arab Republic in 1975 to that in 1977?
Offer a very short reply. 0.9. What is the ratio of the Production index(2004-2006) of India in 1975 to that in 1978?
Offer a terse response. 0.9. What is the ratio of the Production index(2004-2006) in Seychelles in 1975 to that in 1978?
Make the answer very short. 1.13. What is the ratio of the Production index(2004-2006) in St. Lucia in 1975 to that in 1978?
Ensure brevity in your answer.  0.85. What is the ratio of the Production index(2004-2006) of Syrian Arab Republic in 1975 to that in 1978?
Your answer should be compact. 0.78. What is the ratio of the Production index(2004-2006) of India in 1975 to that in 1979?
Give a very brief answer. 0.95. What is the ratio of the Production index(2004-2006) of Seychelles in 1975 to that in 1979?
Offer a very short reply. 1.02. What is the ratio of the Production index(2004-2006) of St. Lucia in 1975 to that in 1979?
Your response must be concise. 0.87. What is the ratio of the Production index(2004-2006) in Syrian Arab Republic in 1975 to that in 1979?
Ensure brevity in your answer.  0.84. What is the ratio of the Production index(2004-2006) in India in 1976 to that in 1977?
Keep it short and to the point. 0.92. What is the ratio of the Production index(2004-2006) in Seychelles in 1976 to that in 1977?
Keep it short and to the point. 1.08. What is the ratio of the Production index(2004-2006) in St. Lucia in 1976 to that in 1977?
Offer a terse response. 1. What is the ratio of the Production index(2004-2006) in Syrian Arab Republic in 1976 to that in 1977?
Ensure brevity in your answer.  1.03. What is the ratio of the Production index(2004-2006) of India in 1976 to that in 1978?
Make the answer very short. 0.9. What is the ratio of the Production index(2004-2006) in Seychelles in 1976 to that in 1978?
Your answer should be very brief. 1.14. What is the ratio of the Production index(2004-2006) of St. Lucia in 1976 to that in 1978?
Keep it short and to the point. 0.91. What is the ratio of the Production index(2004-2006) in Syrian Arab Republic in 1976 to that in 1978?
Give a very brief answer. 0.89. What is the ratio of the Production index(2004-2006) in India in 1976 to that in 1979?
Your response must be concise. 0.94. What is the ratio of the Production index(2004-2006) in Seychelles in 1976 to that in 1979?
Your answer should be very brief. 1.03. What is the ratio of the Production index(2004-2006) in St. Lucia in 1976 to that in 1979?
Give a very brief answer. 0.93. What is the ratio of the Production index(2004-2006) in Syrian Arab Republic in 1976 to that in 1979?
Give a very brief answer. 0.96. What is the ratio of the Production index(2004-2006) of India in 1977 to that in 1978?
Your response must be concise. 0.97. What is the ratio of the Production index(2004-2006) of Seychelles in 1977 to that in 1978?
Provide a short and direct response. 1.06. What is the ratio of the Production index(2004-2006) of St. Lucia in 1977 to that in 1978?
Ensure brevity in your answer.  0.91. What is the ratio of the Production index(2004-2006) of Syrian Arab Republic in 1977 to that in 1978?
Your answer should be compact. 0.86. What is the ratio of the Production index(2004-2006) in India in 1977 to that in 1979?
Your response must be concise. 1.02. What is the ratio of the Production index(2004-2006) in Seychelles in 1977 to that in 1979?
Make the answer very short. 0.95. What is the ratio of the Production index(2004-2006) of St. Lucia in 1977 to that in 1979?
Give a very brief answer. 0.93. What is the ratio of the Production index(2004-2006) of Syrian Arab Republic in 1977 to that in 1979?
Your answer should be compact. 0.93. What is the ratio of the Production index(2004-2006) of India in 1978 to that in 1979?
Your answer should be very brief. 1.05. What is the ratio of the Production index(2004-2006) in Seychelles in 1978 to that in 1979?
Your answer should be compact. 0.9. What is the ratio of the Production index(2004-2006) in St. Lucia in 1978 to that in 1979?
Offer a very short reply. 1.03. What is the ratio of the Production index(2004-2006) in Syrian Arab Republic in 1978 to that in 1979?
Give a very brief answer. 1.08. What is the difference between the highest and the second highest Production index(2004-2006) of India?
Your answer should be very brief. 1.46. What is the difference between the highest and the second highest Production index(2004-2006) in Seychelles?
Ensure brevity in your answer.  3.16. What is the difference between the highest and the second highest Production index(2004-2006) of St. Lucia?
Your answer should be very brief. 3.11. What is the difference between the highest and the second highest Production index(2004-2006) in Syrian Arab Republic?
Provide a succinct answer. 2.68. What is the difference between the highest and the lowest Production index(2004-2006) of India?
Provide a short and direct response. 8.97. What is the difference between the highest and the lowest Production index(2004-2006) in Seychelles?
Your response must be concise. 28.14. What is the difference between the highest and the lowest Production index(2004-2006) of St. Lucia?
Give a very brief answer. 29.14. What is the difference between the highest and the lowest Production index(2004-2006) of Syrian Arab Republic?
Your response must be concise. 20.05. 